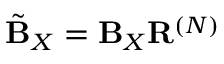Convert formula to latex. <formula><loc_0><loc_0><loc_500><loc_500>\tilde { B } _ { X } = B _ { X } R ^ { ( N ) }</formula> 